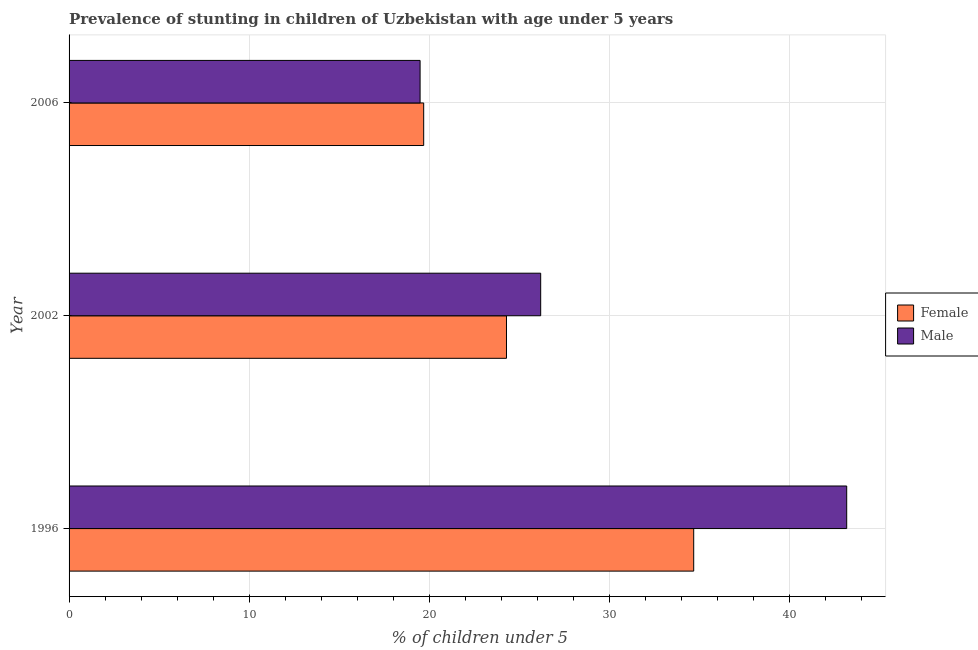How many different coloured bars are there?
Provide a short and direct response. 2. Are the number of bars per tick equal to the number of legend labels?
Offer a terse response. Yes. How many bars are there on the 3rd tick from the top?
Your response must be concise. 2. How many bars are there on the 2nd tick from the bottom?
Offer a very short reply. 2. In how many cases, is the number of bars for a given year not equal to the number of legend labels?
Ensure brevity in your answer.  0. What is the percentage of stunted male children in 2002?
Offer a very short reply. 26.2. Across all years, what is the maximum percentage of stunted female children?
Provide a succinct answer. 34.7. Across all years, what is the minimum percentage of stunted female children?
Provide a short and direct response. 19.7. In which year was the percentage of stunted male children maximum?
Offer a terse response. 1996. What is the total percentage of stunted female children in the graph?
Ensure brevity in your answer.  78.7. What is the difference between the percentage of stunted male children in 1996 and the percentage of stunted female children in 2006?
Offer a very short reply. 23.5. What is the average percentage of stunted male children per year?
Ensure brevity in your answer.  29.63. What is the ratio of the percentage of stunted male children in 2002 to that in 2006?
Provide a short and direct response. 1.34. Is the difference between the percentage of stunted male children in 1996 and 2006 greater than the difference between the percentage of stunted female children in 1996 and 2006?
Offer a very short reply. Yes. What is the difference between the highest and the second highest percentage of stunted male children?
Provide a short and direct response. 17. What is the difference between the highest and the lowest percentage of stunted male children?
Keep it short and to the point. 23.7. What does the 1st bar from the top in 2006 represents?
Ensure brevity in your answer.  Male. What does the 2nd bar from the bottom in 2006 represents?
Keep it short and to the point. Male. How many bars are there?
Offer a terse response. 6. Are all the bars in the graph horizontal?
Keep it short and to the point. Yes. What is the difference between two consecutive major ticks on the X-axis?
Offer a very short reply. 10. Does the graph contain any zero values?
Your answer should be compact. No. Does the graph contain grids?
Offer a terse response. Yes. Where does the legend appear in the graph?
Ensure brevity in your answer.  Center right. How many legend labels are there?
Your response must be concise. 2. What is the title of the graph?
Ensure brevity in your answer.  Prevalence of stunting in children of Uzbekistan with age under 5 years. What is the label or title of the X-axis?
Your answer should be very brief.  % of children under 5. What is the  % of children under 5 in Female in 1996?
Offer a terse response. 34.7. What is the  % of children under 5 of Male in 1996?
Keep it short and to the point. 43.2. What is the  % of children under 5 of Female in 2002?
Give a very brief answer. 24.3. What is the  % of children under 5 of Male in 2002?
Make the answer very short. 26.2. What is the  % of children under 5 in Female in 2006?
Provide a short and direct response. 19.7. Across all years, what is the maximum  % of children under 5 of Female?
Provide a short and direct response. 34.7. Across all years, what is the maximum  % of children under 5 in Male?
Offer a very short reply. 43.2. Across all years, what is the minimum  % of children under 5 of Female?
Ensure brevity in your answer.  19.7. What is the total  % of children under 5 of Female in the graph?
Offer a very short reply. 78.7. What is the total  % of children under 5 in Male in the graph?
Keep it short and to the point. 88.9. What is the difference between the  % of children under 5 of Female in 1996 and that in 2002?
Make the answer very short. 10.4. What is the difference between the  % of children under 5 in Male in 1996 and that in 2002?
Your answer should be compact. 17. What is the difference between the  % of children under 5 in Male in 1996 and that in 2006?
Your answer should be very brief. 23.7. What is the difference between the  % of children under 5 in Female in 2002 and that in 2006?
Keep it short and to the point. 4.6. What is the difference between the  % of children under 5 of Female in 1996 and the  % of children under 5 of Male in 2002?
Keep it short and to the point. 8.5. What is the difference between the  % of children under 5 in Female in 1996 and the  % of children under 5 in Male in 2006?
Provide a succinct answer. 15.2. What is the average  % of children under 5 in Female per year?
Make the answer very short. 26.23. What is the average  % of children under 5 of Male per year?
Offer a very short reply. 29.63. In the year 1996, what is the difference between the  % of children under 5 of Female and  % of children under 5 of Male?
Ensure brevity in your answer.  -8.5. What is the ratio of the  % of children under 5 in Female in 1996 to that in 2002?
Make the answer very short. 1.43. What is the ratio of the  % of children under 5 in Male in 1996 to that in 2002?
Offer a very short reply. 1.65. What is the ratio of the  % of children under 5 in Female in 1996 to that in 2006?
Give a very brief answer. 1.76. What is the ratio of the  % of children under 5 in Male in 1996 to that in 2006?
Offer a terse response. 2.22. What is the ratio of the  % of children under 5 of Female in 2002 to that in 2006?
Your answer should be very brief. 1.23. What is the ratio of the  % of children under 5 in Male in 2002 to that in 2006?
Your answer should be compact. 1.34. What is the difference between the highest and the second highest  % of children under 5 of Female?
Give a very brief answer. 10.4. What is the difference between the highest and the lowest  % of children under 5 in Female?
Keep it short and to the point. 15. What is the difference between the highest and the lowest  % of children under 5 in Male?
Make the answer very short. 23.7. 